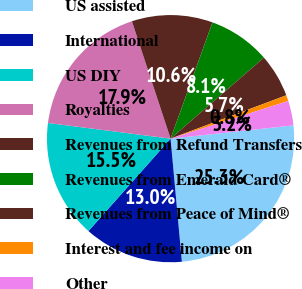Convert chart to OTSL. <chart><loc_0><loc_0><loc_500><loc_500><pie_chart><fcel>US assisted<fcel>International<fcel>US DIY<fcel>Royalties<fcel>Revenues from Refund Transfers<fcel>Revenues from Emerald Card®<fcel>Revenues from Peace of Mind®<fcel>Interest and fee income on<fcel>Other<nl><fcel>25.26%<fcel>13.02%<fcel>15.46%<fcel>17.91%<fcel>10.57%<fcel>8.12%<fcel>5.67%<fcel>0.77%<fcel>3.22%<nl></chart> 